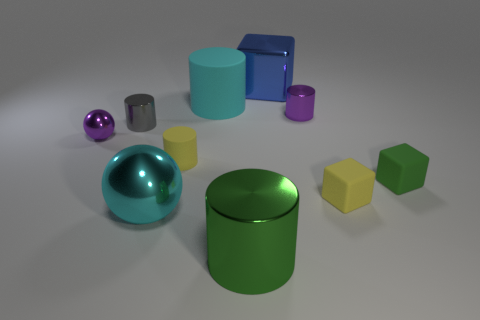Subtract all brown cylinders. Subtract all brown spheres. How many cylinders are left? 5 Subtract all blocks. How many objects are left? 7 Subtract all tiny yellow cylinders. Subtract all big balls. How many objects are left? 8 Add 8 green metal things. How many green metal things are left? 9 Add 1 small yellow metal blocks. How many small yellow metal blocks exist? 1 Subtract 1 purple cylinders. How many objects are left? 9 